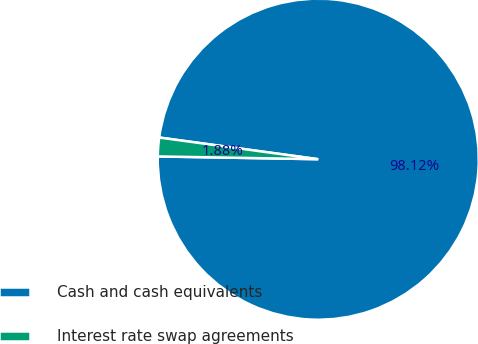Convert chart. <chart><loc_0><loc_0><loc_500><loc_500><pie_chart><fcel>Cash and cash equivalents<fcel>Interest rate swap agreements<nl><fcel>98.12%<fcel>1.88%<nl></chart> 